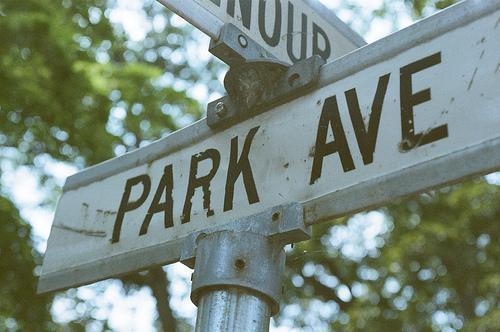How many signs are there?
Give a very brief answer. 2. 